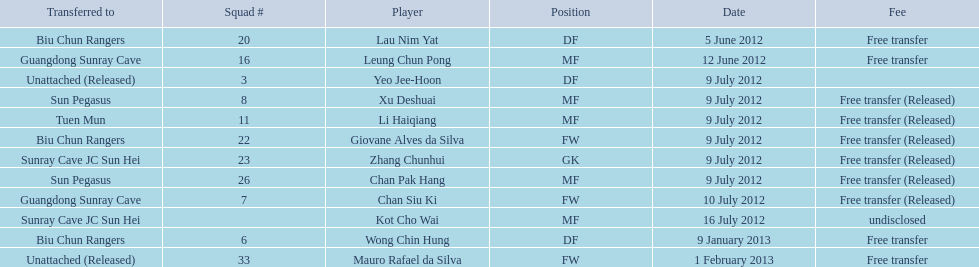Which players played during the 2012-13 south china aa season? Lau Nim Yat, Leung Chun Pong, Yeo Jee-Hoon, Xu Deshuai, Li Haiqiang, Giovane Alves da Silva, Zhang Chunhui, Chan Pak Hang, Chan Siu Ki, Kot Cho Wai, Wong Chin Hung, Mauro Rafael da Silva. Of these, which were free transfers that were not released? Lau Nim Yat, Leung Chun Pong, Wong Chin Hung, Mauro Rafael da Silva. Of these, which were in squad # 6? Wong Chin Hung. What was the date of his transfer? 9 January 2013. 